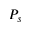<formula> <loc_0><loc_0><loc_500><loc_500>P _ { s }</formula> 